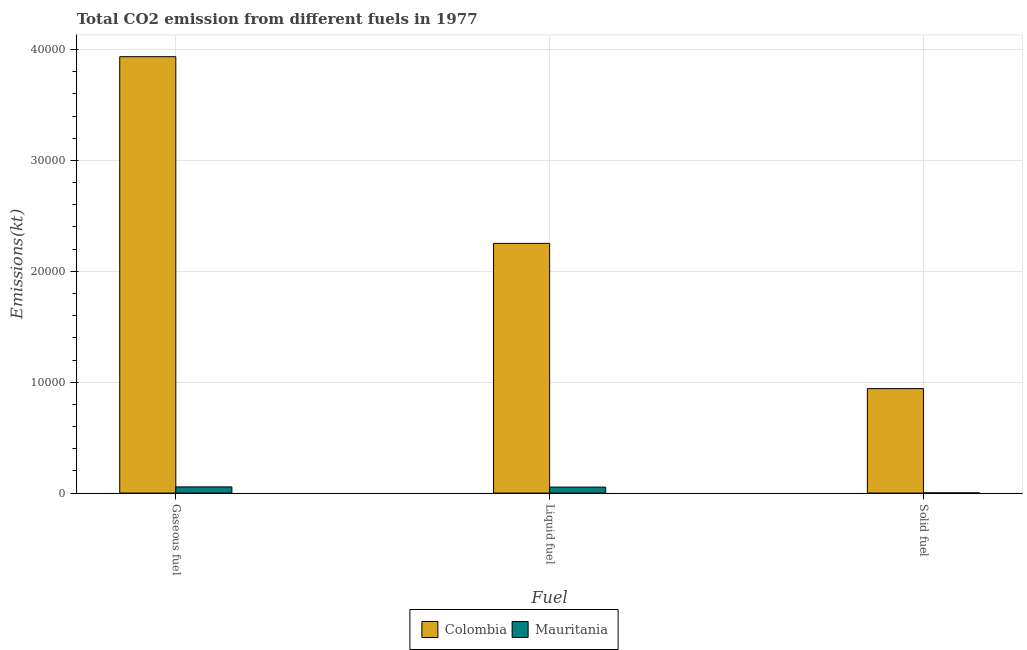Are the number of bars per tick equal to the number of legend labels?
Give a very brief answer. Yes. How many bars are there on the 1st tick from the left?
Keep it short and to the point. 2. What is the label of the 2nd group of bars from the left?
Ensure brevity in your answer.  Liquid fuel. What is the amount of co2 emissions from gaseous fuel in Mauritania?
Ensure brevity in your answer.  557.38. Across all countries, what is the maximum amount of co2 emissions from gaseous fuel?
Make the answer very short. 3.94e+04. Across all countries, what is the minimum amount of co2 emissions from solid fuel?
Offer a terse response. 14.67. In which country was the amount of co2 emissions from solid fuel maximum?
Your answer should be compact. Colombia. In which country was the amount of co2 emissions from solid fuel minimum?
Ensure brevity in your answer.  Mauritania. What is the total amount of co2 emissions from gaseous fuel in the graph?
Offer a terse response. 3.99e+04. What is the difference between the amount of co2 emissions from gaseous fuel in Mauritania and that in Colombia?
Your answer should be compact. -3.88e+04. What is the difference between the amount of co2 emissions from liquid fuel in Mauritania and the amount of co2 emissions from solid fuel in Colombia?
Your response must be concise. -8881.47. What is the average amount of co2 emissions from gaseous fuel per country?
Ensure brevity in your answer.  2.00e+04. What is the difference between the amount of co2 emissions from liquid fuel and amount of co2 emissions from gaseous fuel in Colombia?
Your answer should be compact. -1.68e+04. In how many countries, is the amount of co2 emissions from solid fuel greater than 32000 kt?
Your answer should be compact. 0. What is the ratio of the amount of co2 emissions from solid fuel in Colombia to that in Mauritania?
Provide a short and direct response. 642.25. Is the amount of co2 emissions from gaseous fuel in Colombia less than that in Mauritania?
Offer a terse response. No. What is the difference between the highest and the second highest amount of co2 emissions from gaseous fuel?
Your answer should be compact. 3.88e+04. What is the difference between the highest and the lowest amount of co2 emissions from liquid fuel?
Make the answer very short. 2.20e+04. Is the sum of the amount of co2 emissions from gaseous fuel in Mauritania and Colombia greater than the maximum amount of co2 emissions from liquid fuel across all countries?
Provide a succinct answer. Yes. What does the 2nd bar from the left in Solid fuel represents?
Your answer should be very brief. Mauritania. What does the 2nd bar from the right in Solid fuel represents?
Make the answer very short. Colombia. Is it the case that in every country, the sum of the amount of co2 emissions from gaseous fuel and amount of co2 emissions from liquid fuel is greater than the amount of co2 emissions from solid fuel?
Provide a succinct answer. Yes. Are all the bars in the graph horizontal?
Your answer should be compact. No. What is the difference between two consecutive major ticks on the Y-axis?
Provide a succinct answer. 10000. Are the values on the major ticks of Y-axis written in scientific E-notation?
Keep it short and to the point. No. Does the graph contain any zero values?
Your response must be concise. No. What is the title of the graph?
Your answer should be very brief. Total CO2 emission from different fuels in 1977. What is the label or title of the X-axis?
Give a very brief answer. Fuel. What is the label or title of the Y-axis?
Make the answer very short. Emissions(kt). What is the Emissions(kt) of Colombia in Gaseous fuel?
Provide a short and direct response. 3.94e+04. What is the Emissions(kt) in Mauritania in Gaseous fuel?
Give a very brief answer. 557.38. What is the Emissions(kt) of Colombia in Liquid fuel?
Your response must be concise. 2.25e+04. What is the Emissions(kt) of Mauritania in Liquid fuel?
Provide a succinct answer. 539.05. What is the Emissions(kt) of Colombia in Solid fuel?
Your response must be concise. 9420.52. What is the Emissions(kt) of Mauritania in Solid fuel?
Your answer should be very brief. 14.67. Across all Fuel, what is the maximum Emissions(kt) of Colombia?
Offer a terse response. 3.94e+04. Across all Fuel, what is the maximum Emissions(kt) of Mauritania?
Keep it short and to the point. 557.38. Across all Fuel, what is the minimum Emissions(kt) of Colombia?
Your response must be concise. 9420.52. Across all Fuel, what is the minimum Emissions(kt) in Mauritania?
Give a very brief answer. 14.67. What is the total Emissions(kt) of Colombia in the graph?
Offer a very short reply. 7.13e+04. What is the total Emissions(kt) in Mauritania in the graph?
Offer a very short reply. 1111.1. What is the difference between the Emissions(kt) in Colombia in Gaseous fuel and that in Liquid fuel?
Your answer should be very brief. 1.68e+04. What is the difference between the Emissions(kt) of Mauritania in Gaseous fuel and that in Liquid fuel?
Make the answer very short. 18.34. What is the difference between the Emissions(kt) in Colombia in Gaseous fuel and that in Solid fuel?
Offer a terse response. 2.99e+04. What is the difference between the Emissions(kt) of Mauritania in Gaseous fuel and that in Solid fuel?
Provide a succinct answer. 542.72. What is the difference between the Emissions(kt) of Colombia in Liquid fuel and that in Solid fuel?
Make the answer very short. 1.31e+04. What is the difference between the Emissions(kt) of Mauritania in Liquid fuel and that in Solid fuel?
Provide a short and direct response. 524.38. What is the difference between the Emissions(kt) in Colombia in Gaseous fuel and the Emissions(kt) in Mauritania in Liquid fuel?
Your answer should be compact. 3.88e+04. What is the difference between the Emissions(kt) in Colombia in Gaseous fuel and the Emissions(kt) in Mauritania in Solid fuel?
Provide a succinct answer. 3.93e+04. What is the difference between the Emissions(kt) in Colombia in Liquid fuel and the Emissions(kt) in Mauritania in Solid fuel?
Keep it short and to the point. 2.25e+04. What is the average Emissions(kt) in Colombia per Fuel?
Your answer should be compact. 2.38e+04. What is the average Emissions(kt) of Mauritania per Fuel?
Ensure brevity in your answer.  370.37. What is the difference between the Emissions(kt) in Colombia and Emissions(kt) in Mauritania in Gaseous fuel?
Your answer should be very brief. 3.88e+04. What is the difference between the Emissions(kt) in Colombia and Emissions(kt) in Mauritania in Liquid fuel?
Give a very brief answer. 2.20e+04. What is the difference between the Emissions(kt) of Colombia and Emissions(kt) of Mauritania in Solid fuel?
Make the answer very short. 9405.85. What is the ratio of the Emissions(kt) of Colombia in Gaseous fuel to that in Liquid fuel?
Ensure brevity in your answer.  1.75. What is the ratio of the Emissions(kt) in Mauritania in Gaseous fuel to that in Liquid fuel?
Provide a short and direct response. 1.03. What is the ratio of the Emissions(kt) in Colombia in Gaseous fuel to that in Solid fuel?
Your response must be concise. 4.18. What is the ratio of the Emissions(kt) in Mauritania in Gaseous fuel to that in Solid fuel?
Offer a very short reply. 38. What is the ratio of the Emissions(kt) in Colombia in Liquid fuel to that in Solid fuel?
Ensure brevity in your answer.  2.39. What is the ratio of the Emissions(kt) in Mauritania in Liquid fuel to that in Solid fuel?
Ensure brevity in your answer.  36.75. What is the difference between the highest and the second highest Emissions(kt) in Colombia?
Ensure brevity in your answer.  1.68e+04. What is the difference between the highest and the second highest Emissions(kt) of Mauritania?
Offer a terse response. 18.34. What is the difference between the highest and the lowest Emissions(kt) in Colombia?
Your response must be concise. 2.99e+04. What is the difference between the highest and the lowest Emissions(kt) of Mauritania?
Make the answer very short. 542.72. 